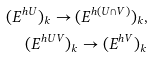<formula> <loc_0><loc_0><loc_500><loc_500>( E ^ { h U } ) _ { k } \rightarrow ( E ^ { h ( U \cap V ) } ) _ { k } , \\ ( E ^ { h U V } ) _ { k } \rightarrow ( E ^ { h V } ) _ { k }</formula> 